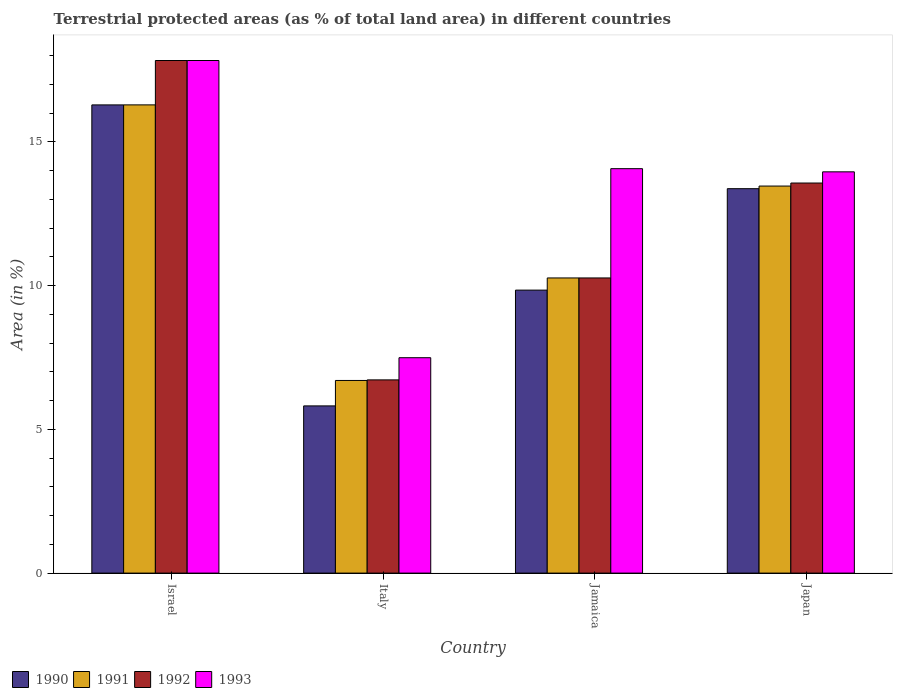How many different coloured bars are there?
Provide a succinct answer. 4. How many groups of bars are there?
Give a very brief answer. 4. What is the percentage of terrestrial protected land in 1991 in Israel?
Offer a terse response. 16.29. Across all countries, what is the maximum percentage of terrestrial protected land in 1990?
Your response must be concise. 16.29. Across all countries, what is the minimum percentage of terrestrial protected land in 1992?
Offer a terse response. 6.72. What is the total percentage of terrestrial protected land in 1992 in the graph?
Give a very brief answer. 48.4. What is the difference between the percentage of terrestrial protected land in 1992 in Italy and that in Japan?
Keep it short and to the point. -6.85. What is the difference between the percentage of terrestrial protected land in 1991 in Japan and the percentage of terrestrial protected land in 1993 in Italy?
Your answer should be compact. 5.97. What is the average percentage of terrestrial protected land in 1993 per country?
Your answer should be very brief. 13.34. What is the difference between the percentage of terrestrial protected land of/in 1990 and percentage of terrestrial protected land of/in 1991 in Japan?
Give a very brief answer. -0.09. What is the ratio of the percentage of terrestrial protected land in 1991 in Jamaica to that in Japan?
Make the answer very short. 0.76. Is the percentage of terrestrial protected land in 1993 in Israel less than that in Japan?
Keep it short and to the point. No. Is the difference between the percentage of terrestrial protected land in 1990 in Italy and Jamaica greater than the difference between the percentage of terrestrial protected land in 1991 in Italy and Jamaica?
Your answer should be very brief. No. What is the difference between the highest and the second highest percentage of terrestrial protected land in 1991?
Give a very brief answer. 6.02. What is the difference between the highest and the lowest percentage of terrestrial protected land in 1991?
Provide a succinct answer. 9.59. In how many countries, is the percentage of terrestrial protected land in 1992 greater than the average percentage of terrestrial protected land in 1992 taken over all countries?
Give a very brief answer. 2. What does the 4th bar from the left in Israel represents?
Make the answer very short. 1993. How many bars are there?
Your response must be concise. 16. Are the values on the major ticks of Y-axis written in scientific E-notation?
Keep it short and to the point. No. Does the graph contain grids?
Make the answer very short. No. Where does the legend appear in the graph?
Your response must be concise. Bottom left. How many legend labels are there?
Make the answer very short. 4. How are the legend labels stacked?
Ensure brevity in your answer.  Horizontal. What is the title of the graph?
Ensure brevity in your answer.  Terrestrial protected areas (as % of total land area) in different countries. What is the label or title of the Y-axis?
Offer a very short reply. Area (in %). What is the Area (in %) in 1990 in Israel?
Make the answer very short. 16.29. What is the Area (in %) in 1991 in Israel?
Keep it short and to the point. 16.29. What is the Area (in %) of 1992 in Israel?
Give a very brief answer. 17.83. What is the Area (in %) of 1993 in Israel?
Ensure brevity in your answer.  17.83. What is the Area (in %) in 1990 in Italy?
Provide a succinct answer. 5.82. What is the Area (in %) of 1991 in Italy?
Your response must be concise. 6.7. What is the Area (in %) in 1992 in Italy?
Keep it short and to the point. 6.72. What is the Area (in %) in 1993 in Italy?
Your response must be concise. 7.49. What is the Area (in %) in 1990 in Jamaica?
Give a very brief answer. 9.85. What is the Area (in %) of 1991 in Jamaica?
Make the answer very short. 10.27. What is the Area (in %) in 1992 in Jamaica?
Give a very brief answer. 10.27. What is the Area (in %) in 1993 in Jamaica?
Your answer should be very brief. 14.07. What is the Area (in %) in 1990 in Japan?
Your answer should be very brief. 13.37. What is the Area (in %) in 1991 in Japan?
Your response must be concise. 13.47. What is the Area (in %) in 1992 in Japan?
Make the answer very short. 13.57. What is the Area (in %) of 1993 in Japan?
Provide a succinct answer. 13.96. Across all countries, what is the maximum Area (in %) in 1990?
Offer a terse response. 16.29. Across all countries, what is the maximum Area (in %) of 1991?
Provide a succinct answer. 16.29. Across all countries, what is the maximum Area (in %) of 1992?
Your response must be concise. 17.83. Across all countries, what is the maximum Area (in %) in 1993?
Your response must be concise. 17.83. Across all countries, what is the minimum Area (in %) of 1990?
Your response must be concise. 5.82. Across all countries, what is the minimum Area (in %) in 1991?
Your answer should be compact. 6.7. Across all countries, what is the minimum Area (in %) of 1992?
Ensure brevity in your answer.  6.72. Across all countries, what is the minimum Area (in %) in 1993?
Your answer should be very brief. 7.49. What is the total Area (in %) of 1990 in the graph?
Make the answer very short. 45.33. What is the total Area (in %) of 1991 in the graph?
Ensure brevity in your answer.  46.73. What is the total Area (in %) of 1992 in the graph?
Keep it short and to the point. 48.4. What is the total Area (in %) in 1993 in the graph?
Your answer should be compact. 53.36. What is the difference between the Area (in %) of 1990 in Israel and that in Italy?
Offer a terse response. 10.47. What is the difference between the Area (in %) in 1991 in Israel and that in Italy?
Your answer should be compact. 9.59. What is the difference between the Area (in %) of 1992 in Israel and that in Italy?
Give a very brief answer. 11.11. What is the difference between the Area (in %) of 1993 in Israel and that in Italy?
Ensure brevity in your answer.  10.34. What is the difference between the Area (in %) in 1990 in Israel and that in Jamaica?
Ensure brevity in your answer.  6.44. What is the difference between the Area (in %) in 1991 in Israel and that in Jamaica?
Keep it short and to the point. 6.02. What is the difference between the Area (in %) in 1992 in Israel and that in Jamaica?
Your response must be concise. 7.57. What is the difference between the Area (in %) of 1993 in Israel and that in Jamaica?
Offer a terse response. 3.76. What is the difference between the Area (in %) in 1990 in Israel and that in Japan?
Your answer should be compact. 2.92. What is the difference between the Area (in %) in 1991 in Israel and that in Japan?
Provide a succinct answer. 2.82. What is the difference between the Area (in %) of 1992 in Israel and that in Japan?
Give a very brief answer. 4.26. What is the difference between the Area (in %) of 1993 in Israel and that in Japan?
Your response must be concise. 3.87. What is the difference between the Area (in %) of 1990 in Italy and that in Jamaica?
Your response must be concise. -4.03. What is the difference between the Area (in %) in 1991 in Italy and that in Jamaica?
Give a very brief answer. -3.57. What is the difference between the Area (in %) in 1992 in Italy and that in Jamaica?
Make the answer very short. -3.55. What is the difference between the Area (in %) in 1993 in Italy and that in Jamaica?
Give a very brief answer. -6.58. What is the difference between the Area (in %) in 1990 in Italy and that in Japan?
Your answer should be compact. -7.56. What is the difference between the Area (in %) of 1991 in Italy and that in Japan?
Offer a terse response. -6.76. What is the difference between the Area (in %) of 1992 in Italy and that in Japan?
Offer a very short reply. -6.85. What is the difference between the Area (in %) in 1993 in Italy and that in Japan?
Provide a short and direct response. -6.47. What is the difference between the Area (in %) in 1990 in Jamaica and that in Japan?
Give a very brief answer. -3.53. What is the difference between the Area (in %) of 1991 in Jamaica and that in Japan?
Offer a terse response. -3.2. What is the difference between the Area (in %) of 1992 in Jamaica and that in Japan?
Keep it short and to the point. -3.3. What is the difference between the Area (in %) of 1993 in Jamaica and that in Japan?
Ensure brevity in your answer.  0.11. What is the difference between the Area (in %) in 1990 in Israel and the Area (in %) in 1991 in Italy?
Your answer should be very brief. 9.59. What is the difference between the Area (in %) of 1990 in Israel and the Area (in %) of 1992 in Italy?
Offer a very short reply. 9.57. What is the difference between the Area (in %) of 1990 in Israel and the Area (in %) of 1993 in Italy?
Provide a short and direct response. 8.8. What is the difference between the Area (in %) of 1991 in Israel and the Area (in %) of 1992 in Italy?
Provide a short and direct response. 9.57. What is the difference between the Area (in %) of 1991 in Israel and the Area (in %) of 1993 in Italy?
Your answer should be very brief. 8.8. What is the difference between the Area (in %) in 1992 in Israel and the Area (in %) in 1993 in Italy?
Offer a terse response. 10.34. What is the difference between the Area (in %) in 1990 in Israel and the Area (in %) in 1991 in Jamaica?
Give a very brief answer. 6.02. What is the difference between the Area (in %) of 1990 in Israel and the Area (in %) of 1992 in Jamaica?
Your answer should be compact. 6.02. What is the difference between the Area (in %) in 1990 in Israel and the Area (in %) in 1993 in Jamaica?
Give a very brief answer. 2.22. What is the difference between the Area (in %) of 1991 in Israel and the Area (in %) of 1992 in Jamaica?
Your answer should be very brief. 6.02. What is the difference between the Area (in %) of 1991 in Israel and the Area (in %) of 1993 in Jamaica?
Make the answer very short. 2.22. What is the difference between the Area (in %) in 1992 in Israel and the Area (in %) in 1993 in Jamaica?
Your answer should be compact. 3.76. What is the difference between the Area (in %) of 1990 in Israel and the Area (in %) of 1991 in Japan?
Provide a short and direct response. 2.82. What is the difference between the Area (in %) of 1990 in Israel and the Area (in %) of 1992 in Japan?
Offer a very short reply. 2.72. What is the difference between the Area (in %) in 1990 in Israel and the Area (in %) in 1993 in Japan?
Make the answer very short. 2.33. What is the difference between the Area (in %) of 1991 in Israel and the Area (in %) of 1992 in Japan?
Provide a succinct answer. 2.72. What is the difference between the Area (in %) in 1991 in Israel and the Area (in %) in 1993 in Japan?
Provide a succinct answer. 2.33. What is the difference between the Area (in %) of 1992 in Israel and the Area (in %) of 1993 in Japan?
Offer a very short reply. 3.87. What is the difference between the Area (in %) in 1990 in Italy and the Area (in %) in 1991 in Jamaica?
Your answer should be compact. -4.45. What is the difference between the Area (in %) of 1990 in Italy and the Area (in %) of 1992 in Jamaica?
Ensure brevity in your answer.  -4.45. What is the difference between the Area (in %) of 1990 in Italy and the Area (in %) of 1993 in Jamaica?
Your response must be concise. -8.25. What is the difference between the Area (in %) in 1991 in Italy and the Area (in %) in 1992 in Jamaica?
Offer a terse response. -3.57. What is the difference between the Area (in %) in 1991 in Italy and the Area (in %) in 1993 in Jamaica?
Offer a very short reply. -7.37. What is the difference between the Area (in %) of 1992 in Italy and the Area (in %) of 1993 in Jamaica?
Give a very brief answer. -7.35. What is the difference between the Area (in %) in 1990 in Italy and the Area (in %) in 1991 in Japan?
Offer a very short reply. -7.65. What is the difference between the Area (in %) of 1990 in Italy and the Area (in %) of 1992 in Japan?
Your answer should be very brief. -7.75. What is the difference between the Area (in %) in 1990 in Italy and the Area (in %) in 1993 in Japan?
Keep it short and to the point. -8.14. What is the difference between the Area (in %) of 1991 in Italy and the Area (in %) of 1992 in Japan?
Provide a succinct answer. -6.87. What is the difference between the Area (in %) in 1991 in Italy and the Area (in %) in 1993 in Japan?
Make the answer very short. -7.26. What is the difference between the Area (in %) of 1992 in Italy and the Area (in %) of 1993 in Japan?
Your answer should be compact. -7.24. What is the difference between the Area (in %) of 1990 in Jamaica and the Area (in %) of 1991 in Japan?
Your answer should be very brief. -3.62. What is the difference between the Area (in %) in 1990 in Jamaica and the Area (in %) in 1992 in Japan?
Your answer should be compact. -3.73. What is the difference between the Area (in %) in 1990 in Jamaica and the Area (in %) in 1993 in Japan?
Your answer should be compact. -4.12. What is the difference between the Area (in %) in 1991 in Jamaica and the Area (in %) in 1992 in Japan?
Your answer should be compact. -3.3. What is the difference between the Area (in %) of 1991 in Jamaica and the Area (in %) of 1993 in Japan?
Give a very brief answer. -3.69. What is the difference between the Area (in %) of 1992 in Jamaica and the Area (in %) of 1993 in Japan?
Your response must be concise. -3.69. What is the average Area (in %) in 1990 per country?
Your response must be concise. 11.33. What is the average Area (in %) of 1991 per country?
Provide a succinct answer. 11.68. What is the average Area (in %) of 1992 per country?
Provide a short and direct response. 12.1. What is the average Area (in %) in 1993 per country?
Offer a very short reply. 13.34. What is the difference between the Area (in %) in 1990 and Area (in %) in 1991 in Israel?
Your answer should be compact. -0. What is the difference between the Area (in %) in 1990 and Area (in %) in 1992 in Israel?
Offer a terse response. -1.54. What is the difference between the Area (in %) of 1990 and Area (in %) of 1993 in Israel?
Your answer should be very brief. -1.54. What is the difference between the Area (in %) in 1991 and Area (in %) in 1992 in Israel?
Ensure brevity in your answer.  -1.54. What is the difference between the Area (in %) in 1991 and Area (in %) in 1993 in Israel?
Keep it short and to the point. -1.54. What is the difference between the Area (in %) of 1992 and Area (in %) of 1993 in Israel?
Keep it short and to the point. 0. What is the difference between the Area (in %) in 1990 and Area (in %) in 1991 in Italy?
Keep it short and to the point. -0.89. What is the difference between the Area (in %) in 1990 and Area (in %) in 1992 in Italy?
Provide a short and direct response. -0.91. What is the difference between the Area (in %) in 1990 and Area (in %) in 1993 in Italy?
Offer a very short reply. -1.68. What is the difference between the Area (in %) of 1991 and Area (in %) of 1992 in Italy?
Your answer should be very brief. -0.02. What is the difference between the Area (in %) of 1991 and Area (in %) of 1993 in Italy?
Your answer should be very brief. -0.79. What is the difference between the Area (in %) of 1992 and Area (in %) of 1993 in Italy?
Provide a short and direct response. -0.77. What is the difference between the Area (in %) of 1990 and Area (in %) of 1991 in Jamaica?
Provide a succinct answer. -0.42. What is the difference between the Area (in %) of 1990 and Area (in %) of 1992 in Jamaica?
Offer a very short reply. -0.42. What is the difference between the Area (in %) in 1990 and Area (in %) in 1993 in Jamaica?
Your answer should be compact. -4.23. What is the difference between the Area (in %) in 1991 and Area (in %) in 1993 in Jamaica?
Keep it short and to the point. -3.8. What is the difference between the Area (in %) in 1992 and Area (in %) in 1993 in Jamaica?
Give a very brief answer. -3.8. What is the difference between the Area (in %) of 1990 and Area (in %) of 1991 in Japan?
Keep it short and to the point. -0.09. What is the difference between the Area (in %) of 1990 and Area (in %) of 1992 in Japan?
Offer a very short reply. -0.2. What is the difference between the Area (in %) in 1990 and Area (in %) in 1993 in Japan?
Keep it short and to the point. -0.59. What is the difference between the Area (in %) of 1991 and Area (in %) of 1992 in Japan?
Provide a short and direct response. -0.11. What is the difference between the Area (in %) in 1991 and Area (in %) in 1993 in Japan?
Provide a short and direct response. -0.49. What is the difference between the Area (in %) in 1992 and Area (in %) in 1993 in Japan?
Your answer should be very brief. -0.39. What is the ratio of the Area (in %) of 1990 in Israel to that in Italy?
Provide a succinct answer. 2.8. What is the ratio of the Area (in %) of 1991 in Israel to that in Italy?
Your answer should be compact. 2.43. What is the ratio of the Area (in %) in 1992 in Israel to that in Italy?
Ensure brevity in your answer.  2.65. What is the ratio of the Area (in %) of 1993 in Israel to that in Italy?
Offer a very short reply. 2.38. What is the ratio of the Area (in %) in 1990 in Israel to that in Jamaica?
Your answer should be compact. 1.65. What is the ratio of the Area (in %) in 1991 in Israel to that in Jamaica?
Make the answer very short. 1.59. What is the ratio of the Area (in %) of 1992 in Israel to that in Jamaica?
Your response must be concise. 1.74. What is the ratio of the Area (in %) of 1993 in Israel to that in Jamaica?
Offer a very short reply. 1.27. What is the ratio of the Area (in %) of 1990 in Israel to that in Japan?
Offer a very short reply. 1.22. What is the ratio of the Area (in %) of 1991 in Israel to that in Japan?
Your response must be concise. 1.21. What is the ratio of the Area (in %) in 1992 in Israel to that in Japan?
Ensure brevity in your answer.  1.31. What is the ratio of the Area (in %) of 1993 in Israel to that in Japan?
Your answer should be very brief. 1.28. What is the ratio of the Area (in %) in 1990 in Italy to that in Jamaica?
Your answer should be very brief. 0.59. What is the ratio of the Area (in %) in 1991 in Italy to that in Jamaica?
Offer a terse response. 0.65. What is the ratio of the Area (in %) in 1992 in Italy to that in Jamaica?
Your answer should be very brief. 0.65. What is the ratio of the Area (in %) of 1993 in Italy to that in Jamaica?
Provide a succinct answer. 0.53. What is the ratio of the Area (in %) in 1990 in Italy to that in Japan?
Your answer should be compact. 0.43. What is the ratio of the Area (in %) in 1991 in Italy to that in Japan?
Your answer should be very brief. 0.5. What is the ratio of the Area (in %) in 1992 in Italy to that in Japan?
Your response must be concise. 0.5. What is the ratio of the Area (in %) of 1993 in Italy to that in Japan?
Offer a very short reply. 0.54. What is the ratio of the Area (in %) of 1990 in Jamaica to that in Japan?
Your answer should be compact. 0.74. What is the ratio of the Area (in %) in 1991 in Jamaica to that in Japan?
Your answer should be very brief. 0.76. What is the ratio of the Area (in %) in 1992 in Jamaica to that in Japan?
Give a very brief answer. 0.76. What is the ratio of the Area (in %) in 1993 in Jamaica to that in Japan?
Your answer should be compact. 1.01. What is the difference between the highest and the second highest Area (in %) in 1990?
Ensure brevity in your answer.  2.92. What is the difference between the highest and the second highest Area (in %) of 1991?
Ensure brevity in your answer.  2.82. What is the difference between the highest and the second highest Area (in %) of 1992?
Give a very brief answer. 4.26. What is the difference between the highest and the second highest Area (in %) in 1993?
Provide a succinct answer. 3.76. What is the difference between the highest and the lowest Area (in %) in 1990?
Offer a terse response. 10.47. What is the difference between the highest and the lowest Area (in %) of 1991?
Your response must be concise. 9.59. What is the difference between the highest and the lowest Area (in %) of 1992?
Your answer should be very brief. 11.11. What is the difference between the highest and the lowest Area (in %) in 1993?
Give a very brief answer. 10.34. 